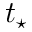<formula> <loc_0><loc_0><loc_500><loc_500>t _ { ^ { * } }</formula> 